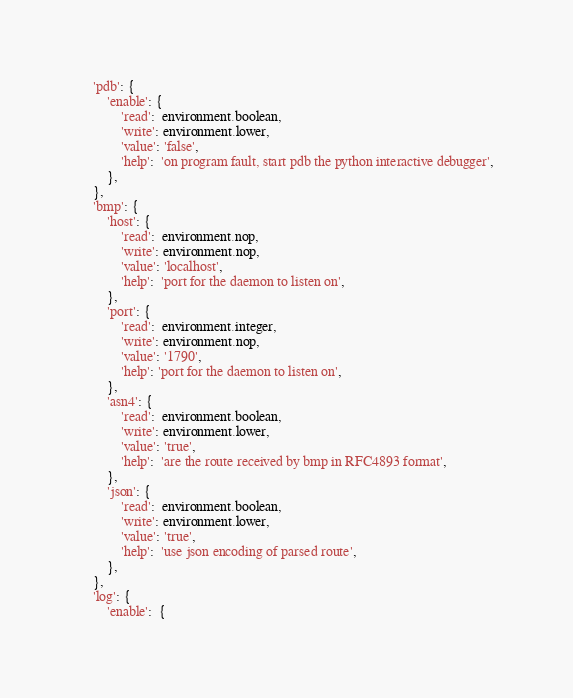Convert code to text. <code><loc_0><loc_0><loc_500><loc_500><_Python_>	'pdb': {
		'enable': {
			'read':  environment.boolean,
			'write': environment.lower,
			'value': 'false',
			'help':  'on program fault, start pdb the python interactive debugger',
		},
	},
	'bmp': {
		'host': {
			'read':  environment.nop,
			'write': environment.nop,
			'value': 'localhost',
			'help':  'port for the daemon to listen on',
		},
		'port': {
			'read':  environment.integer,
			'write': environment.nop,
			'value': '1790',
			'help': 'port for the daemon to listen on',
		},
		'asn4': {
			'read':  environment.boolean,
			'write': environment.lower,
			'value': 'true',
			'help':  'are the route received by bmp in RFC4893 format',
		},
		'json': {
			'read':  environment.boolean,
			'write': environment.lower,
			'value': 'true',
			'help':  'use json encoding of parsed route',
		},
	},
	'log': {
		'enable':  {</code> 